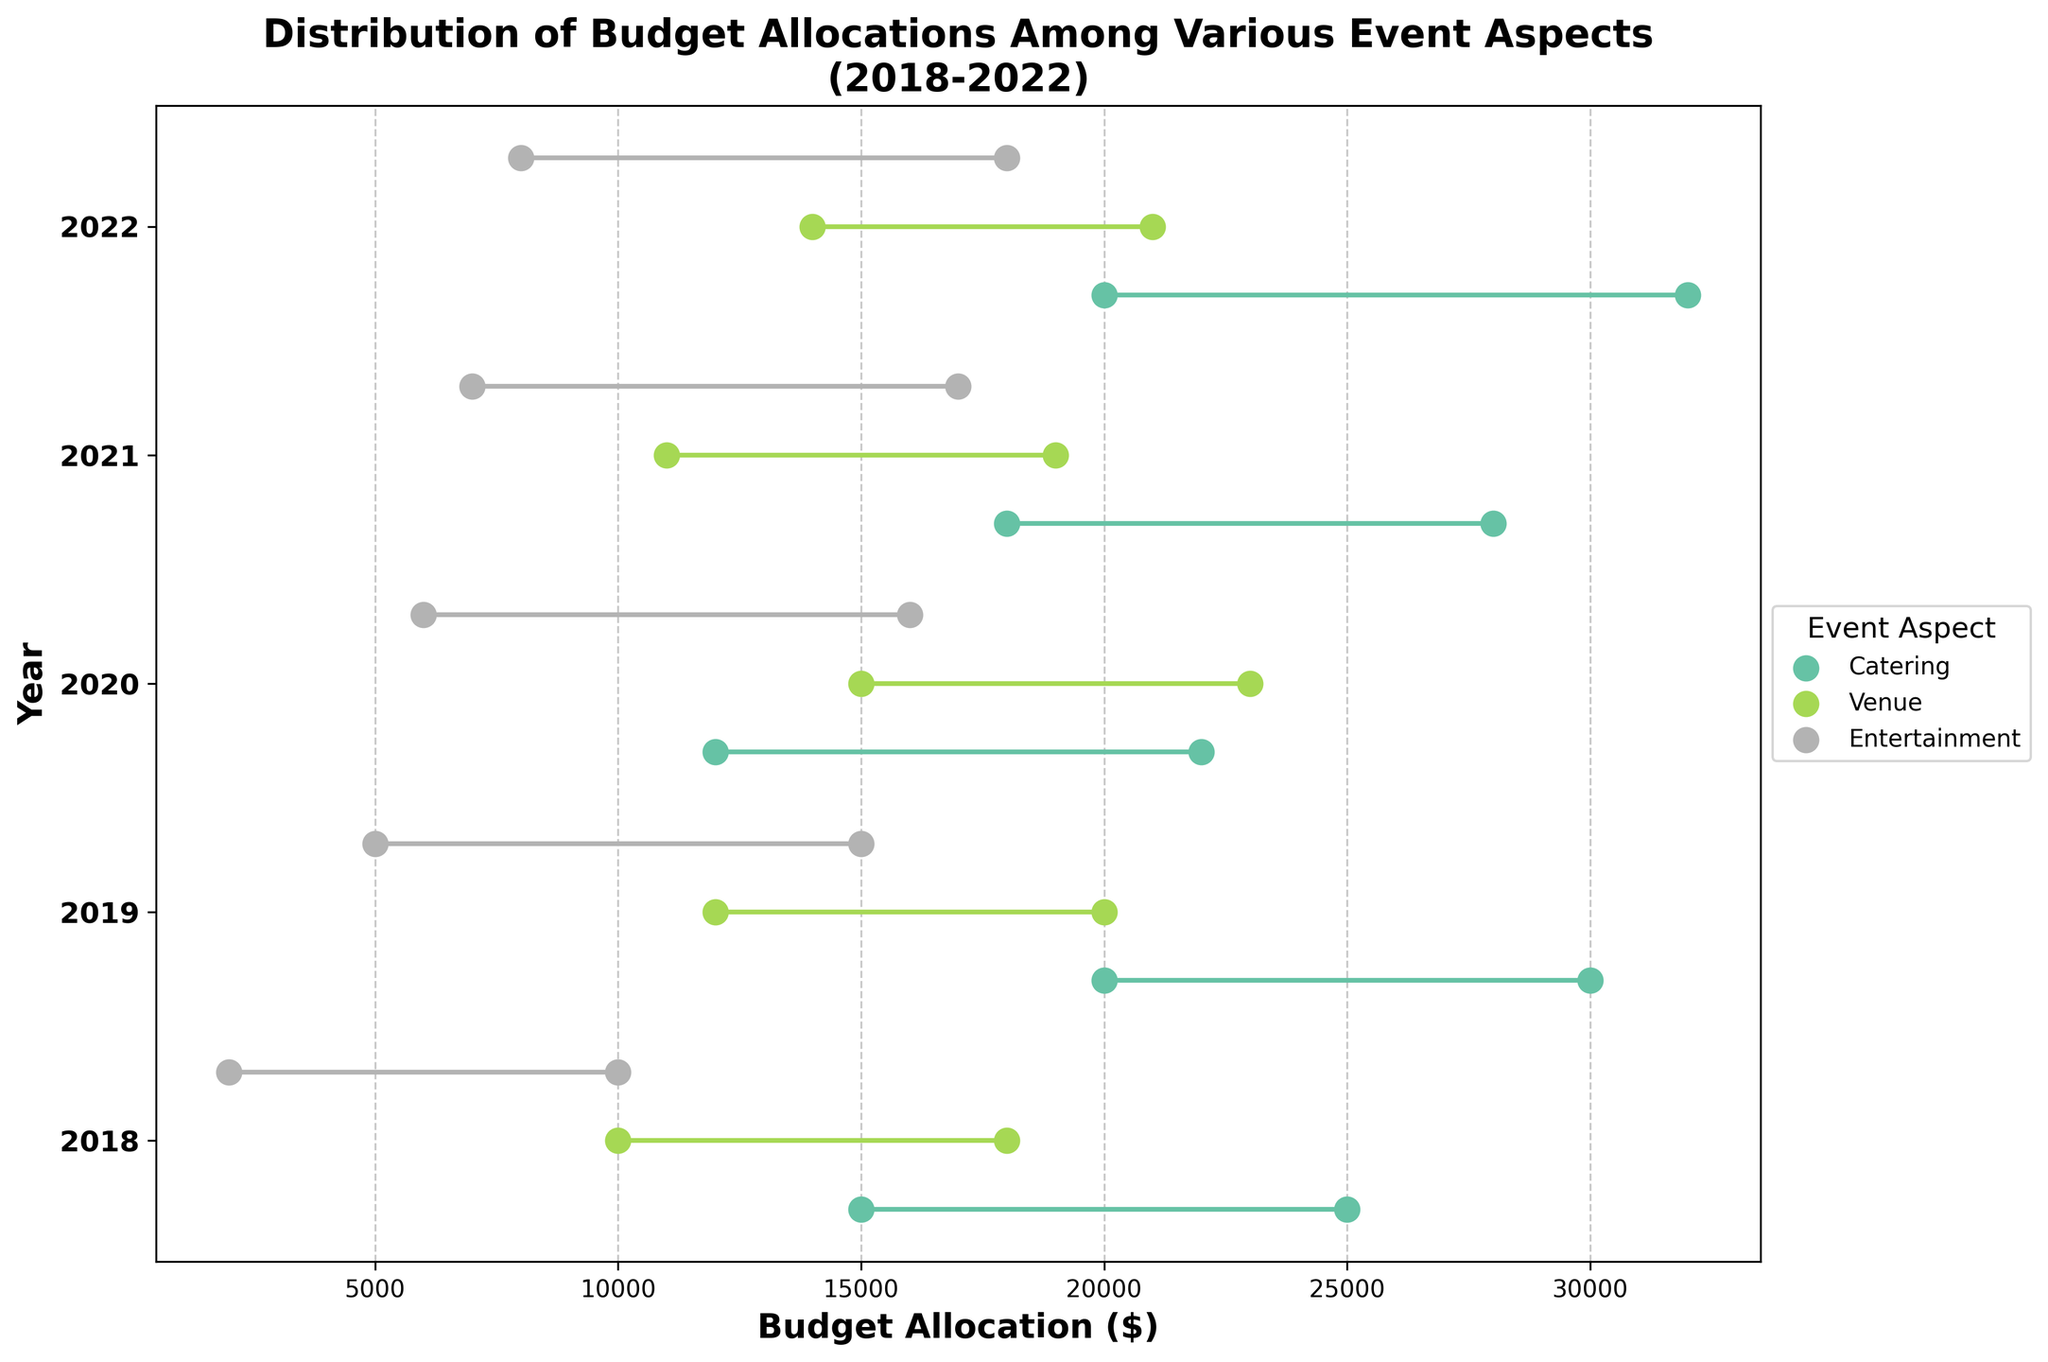What year had the highest maximum budget for Catering? First, identify the category "Catering" from the figure. Then, find the year associated with the highest dot on the plot for "Catering." The year is 2022, and the maximum budget is $32,000.
Answer: 2022 Which event aspect had the smallest budget range in 2020? For each event aspect in 2020, calculate the budget range by subtracting the minimum budget from the maximum budget. Compare the ranges: Catering (22,000-12,000=10,000), Venue (23,000-15,000=8,000), Entertainment (16,000-6,000=10,000). "Venue" has the smallest range.
Answer: Venue What is the average minimum budget for Entertainment over the five years? List the minimum budgets for Entertainment: 2018 ($2000), 2019 ($5000), 2020 ($6000), 2021 ($7000), 2022 ($8000). Sum these values (2000 + 5000 + 6000 + 7000 + 8000 = 28000), and then divide by the number of years (28000 / 5). The average minimum budget is $5,600.
Answer: $5,600 Did any category have a decreasing trend in maximum budget from 2018 to 2022? Compare the maximum budgets for each year within each category. For Catering: 2018 (25000), 2019 (30000), 2020 (22000), 2021 (28000), 2022 (32000), the trend is not consistently decreasing. For Venue and Entertainment, a similar check reveals no consistent downward trend.
Answer: No How much more was the maximum budget for Catering in 2022 compared to 2018? Check the maximum budgets for Catering in 2022 ($32,000) and 2018 ($25,000). Subtract the 2018 value from the 2022 value (32,000 - 25,000). The difference is $7,000.
Answer: $7,000 